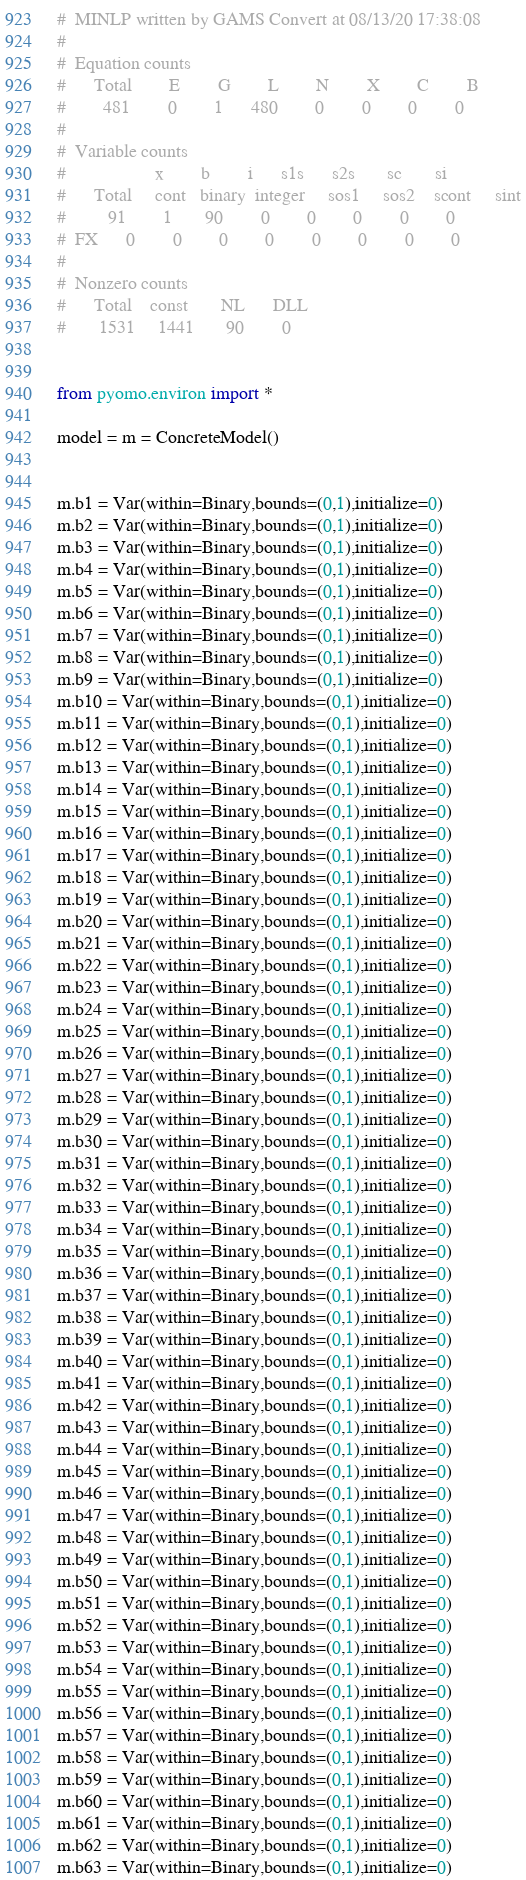<code> <loc_0><loc_0><loc_500><loc_500><_Python_>#  MINLP written by GAMS Convert at 08/13/20 17:38:08
#  
#  Equation counts
#      Total        E        G        L        N        X        C        B
#        481        0        1      480        0        0        0        0
#  
#  Variable counts
#                   x        b        i      s1s      s2s       sc       si
#      Total     cont   binary  integer     sos1     sos2    scont     sint
#         91        1       90        0        0        0        0        0
#  FX      0        0        0        0        0        0        0        0
#  
#  Nonzero counts
#      Total    const       NL      DLL
#       1531     1441       90        0


from pyomo.environ import *

model = m = ConcreteModel()


m.b1 = Var(within=Binary,bounds=(0,1),initialize=0)
m.b2 = Var(within=Binary,bounds=(0,1),initialize=0)
m.b3 = Var(within=Binary,bounds=(0,1),initialize=0)
m.b4 = Var(within=Binary,bounds=(0,1),initialize=0)
m.b5 = Var(within=Binary,bounds=(0,1),initialize=0)
m.b6 = Var(within=Binary,bounds=(0,1),initialize=0)
m.b7 = Var(within=Binary,bounds=(0,1),initialize=0)
m.b8 = Var(within=Binary,bounds=(0,1),initialize=0)
m.b9 = Var(within=Binary,bounds=(0,1),initialize=0)
m.b10 = Var(within=Binary,bounds=(0,1),initialize=0)
m.b11 = Var(within=Binary,bounds=(0,1),initialize=0)
m.b12 = Var(within=Binary,bounds=(0,1),initialize=0)
m.b13 = Var(within=Binary,bounds=(0,1),initialize=0)
m.b14 = Var(within=Binary,bounds=(0,1),initialize=0)
m.b15 = Var(within=Binary,bounds=(0,1),initialize=0)
m.b16 = Var(within=Binary,bounds=(0,1),initialize=0)
m.b17 = Var(within=Binary,bounds=(0,1),initialize=0)
m.b18 = Var(within=Binary,bounds=(0,1),initialize=0)
m.b19 = Var(within=Binary,bounds=(0,1),initialize=0)
m.b20 = Var(within=Binary,bounds=(0,1),initialize=0)
m.b21 = Var(within=Binary,bounds=(0,1),initialize=0)
m.b22 = Var(within=Binary,bounds=(0,1),initialize=0)
m.b23 = Var(within=Binary,bounds=(0,1),initialize=0)
m.b24 = Var(within=Binary,bounds=(0,1),initialize=0)
m.b25 = Var(within=Binary,bounds=(0,1),initialize=0)
m.b26 = Var(within=Binary,bounds=(0,1),initialize=0)
m.b27 = Var(within=Binary,bounds=(0,1),initialize=0)
m.b28 = Var(within=Binary,bounds=(0,1),initialize=0)
m.b29 = Var(within=Binary,bounds=(0,1),initialize=0)
m.b30 = Var(within=Binary,bounds=(0,1),initialize=0)
m.b31 = Var(within=Binary,bounds=(0,1),initialize=0)
m.b32 = Var(within=Binary,bounds=(0,1),initialize=0)
m.b33 = Var(within=Binary,bounds=(0,1),initialize=0)
m.b34 = Var(within=Binary,bounds=(0,1),initialize=0)
m.b35 = Var(within=Binary,bounds=(0,1),initialize=0)
m.b36 = Var(within=Binary,bounds=(0,1),initialize=0)
m.b37 = Var(within=Binary,bounds=(0,1),initialize=0)
m.b38 = Var(within=Binary,bounds=(0,1),initialize=0)
m.b39 = Var(within=Binary,bounds=(0,1),initialize=0)
m.b40 = Var(within=Binary,bounds=(0,1),initialize=0)
m.b41 = Var(within=Binary,bounds=(0,1),initialize=0)
m.b42 = Var(within=Binary,bounds=(0,1),initialize=0)
m.b43 = Var(within=Binary,bounds=(0,1),initialize=0)
m.b44 = Var(within=Binary,bounds=(0,1),initialize=0)
m.b45 = Var(within=Binary,bounds=(0,1),initialize=0)
m.b46 = Var(within=Binary,bounds=(0,1),initialize=0)
m.b47 = Var(within=Binary,bounds=(0,1),initialize=0)
m.b48 = Var(within=Binary,bounds=(0,1),initialize=0)
m.b49 = Var(within=Binary,bounds=(0,1),initialize=0)
m.b50 = Var(within=Binary,bounds=(0,1),initialize=0)
m.b51 = Var(within=Binary,bounds=(0,1),initialize=0)
m.b52 = Var(within=Binary,bounds=(0,1),initialize=0)
m.b53 = Var(within=Binary,bounds=(0,1),initialize=0)
m.b54 = Var(within=Binary,bounds=(0,1),initialize=0)
m.b55 = Var(within=Binary,bounds=(0,1),initialize=0)
m.b56 = Var(within=Binary,bounds=(0,1),initialize=0)
m.b57 = Var(within=Binary,bounds=(0,1),initialize=0)
m.b58 = Var(within=Binary,bounds=(0,1),initialize=0)
m.b59 = Var(within=Binary,bounds=(0,1),initialize=0)
m.b60 = Var(within=Binary,bounds=(0,1),initialize=0)
m.b61 = Var(within=Binary,bounds=(0,1),initialize=0)
m.b62 = Var(within=Binary,bounds=(0,1),initialize=0)
m.b63 = Var(within=Binary,bounds=(0,1),initialize=0)</code> 